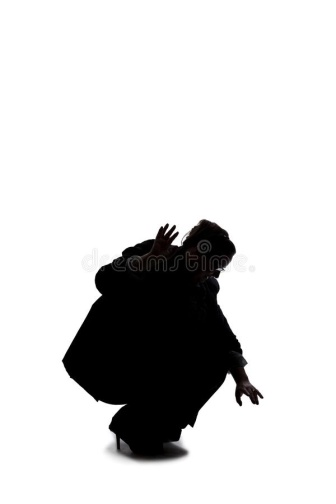What could the figure be crouching in preparation for, in a highly imaginative scenario? In a wild, imaginative scenario, the figure could be a time traveler just arriving in a new, unknown dimension. They crouch low, scanning the alien landscape around them for signs of danger or opportunity. Their hands, poised in a claw-like grip, might be ready to activate some hidden device or weapon embedded in their palms, a futuristic tool for navigating this strange new world. Perhaps they're on a quest, the only one who can retrieve a powerful artifact that will save their timeline from imminent destruction. The stark white background could represent the boundless possibilities of this uncharted dimension, where the traveler must tread carefully but decisively. Imagine a film scene that could be made from this image. In a suspenseful thriller, the scene could take place in a high-stakes espionage scenario. The protagonist, a secret agent, has infiltrated a heavily guarded facility and is now poised to retrieve crucial intelligence. The moment captured is just before they make their move, the white background symbolizing the tension and isolation within the stark, sterile environment of the enemy headquarters. The lighting highlights their silhouette, emphasizing their readiness and the gravity of the mission. As the scene unfolds, viewers would be on the edge of their seats, waiting for the agent to spring into action, evading cameras and guards with agile precision, embodying the intensity of the covert operation. 